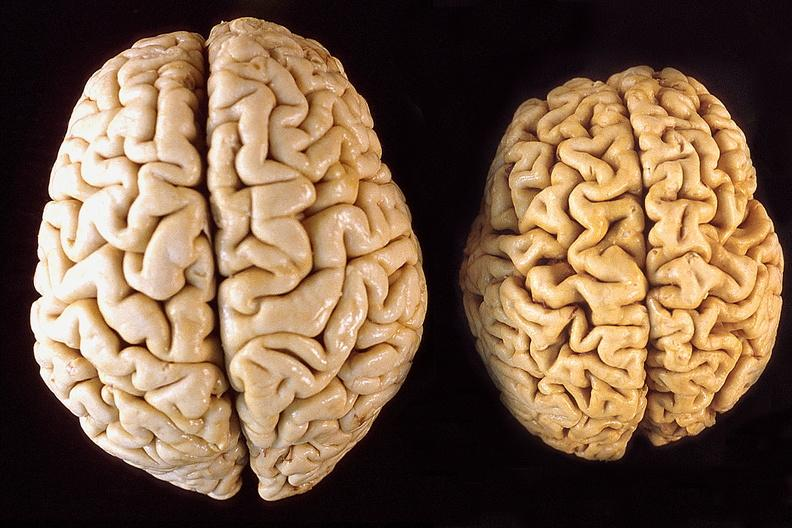what is present?
Answer the question using a single word or phrase. Nervous 